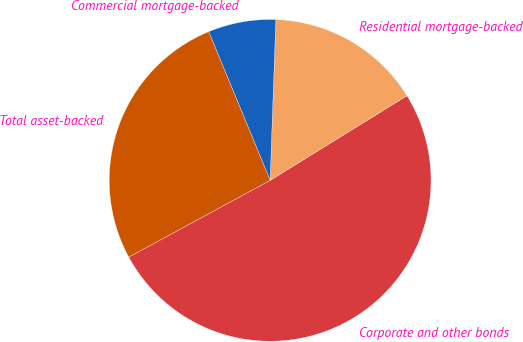Convert chart to OTSL. <chart><loc_0><loc_0><loc_500><loc_500><pie_chart><fcel>Corporate and other bonds<fcel>Residential mortgage-backed<fcel>Commercial mortgage-backed<fcel>Total asset-backed<nl><fcel>50.9%<fcel>15.62%<fcel>6.8%<fcel>26.68%<nl></chart> 